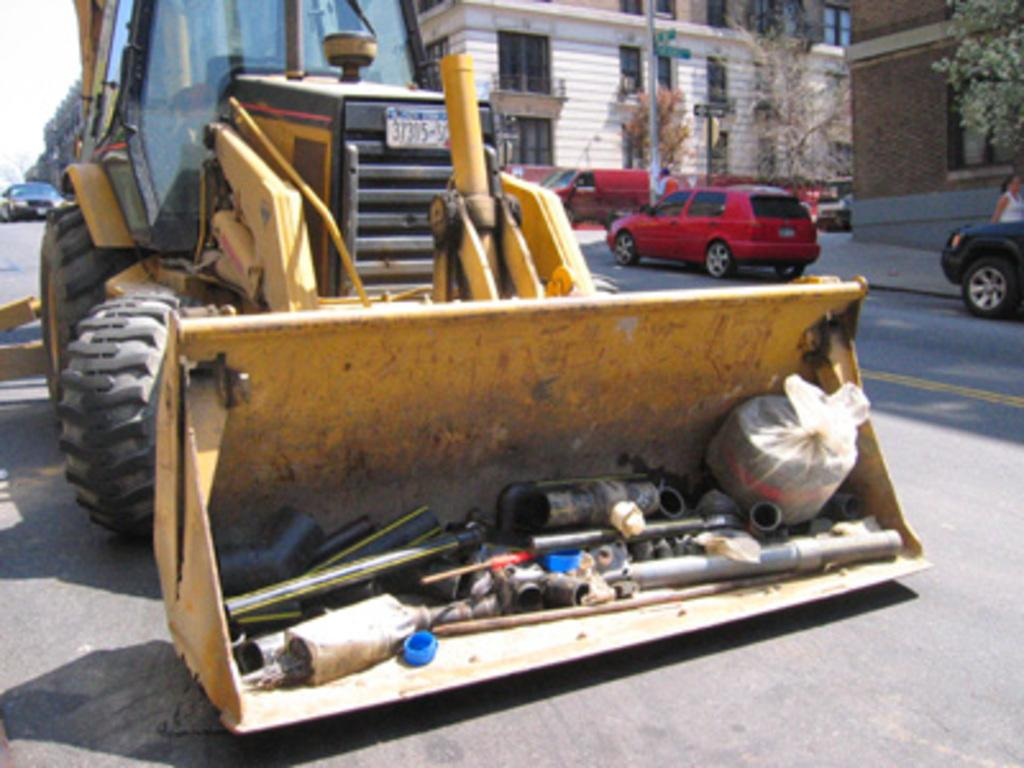What types of objects can be seen in the image? There are vehicles, trees, and buildings in the image. Can you describe the natural elements in the image? There are trees in the image. What is visible in the background of the image? The sky is visible in the background of the image. Is there a volcano erupting in the background of the image? No, there is no volcano present in the image. What type of game is being played in the image? There is no game being played in the image; it features vehicles, trees, and buildings. 